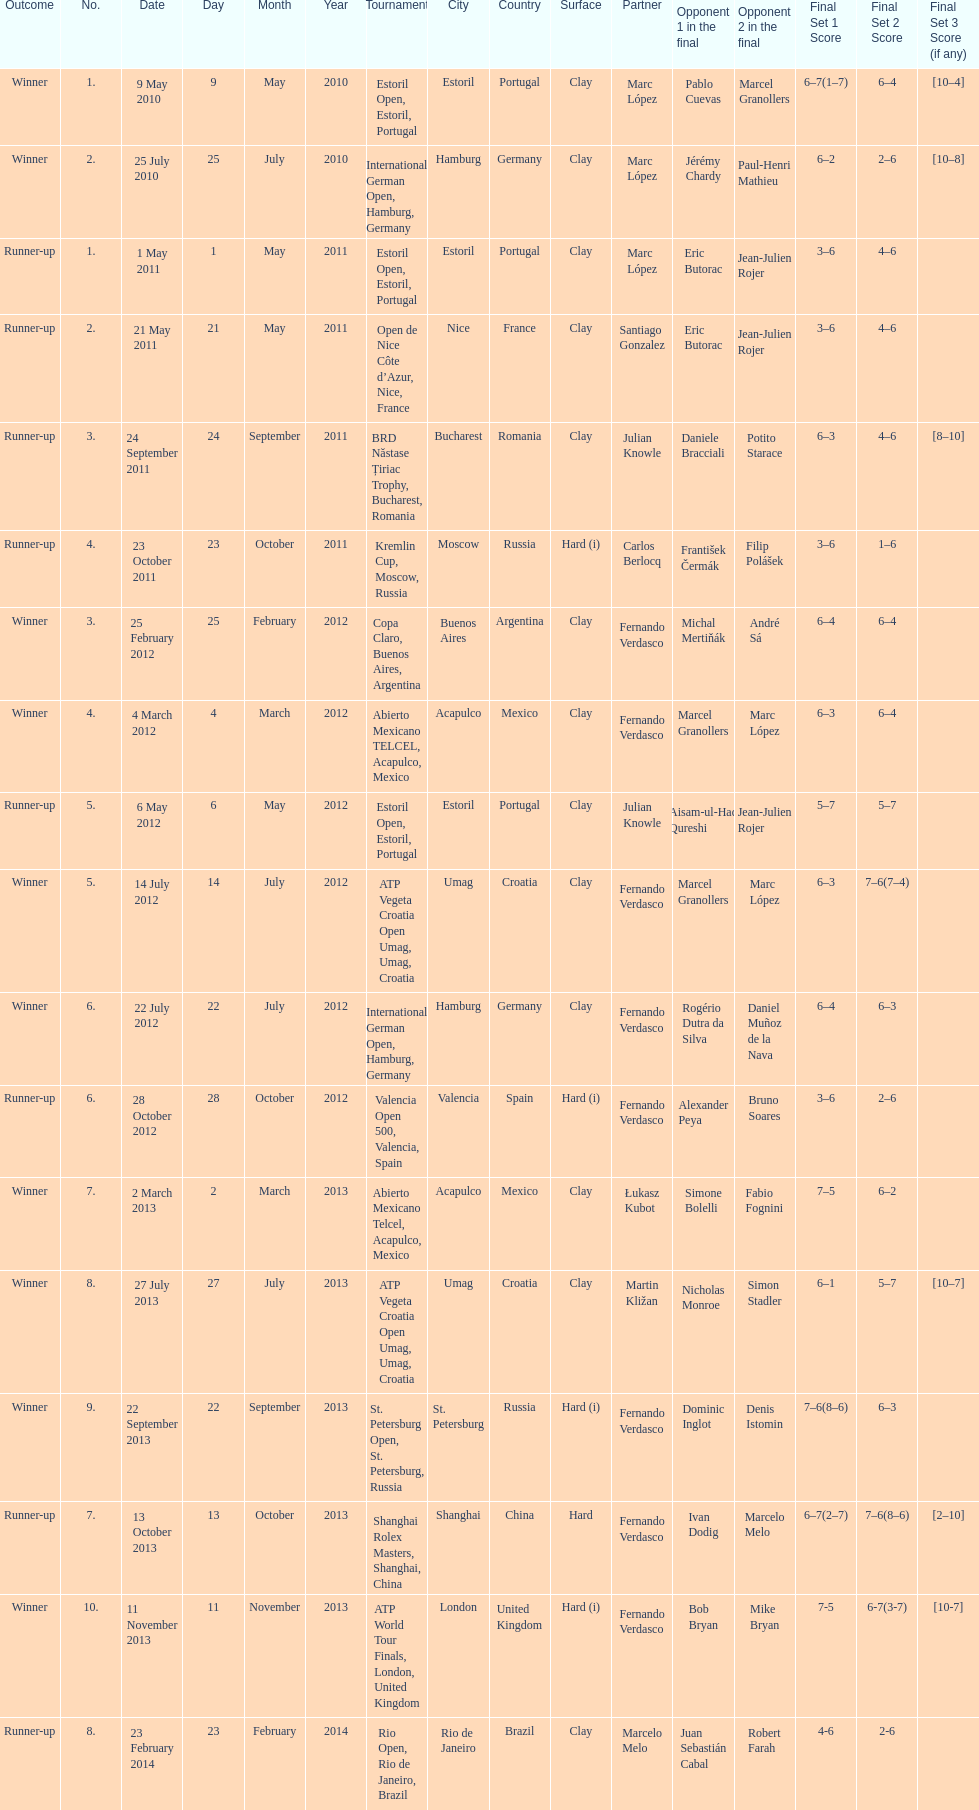What tournament was before the estoril open? Abierto Mexicano TELCEL, Acapulco, Mexico. 